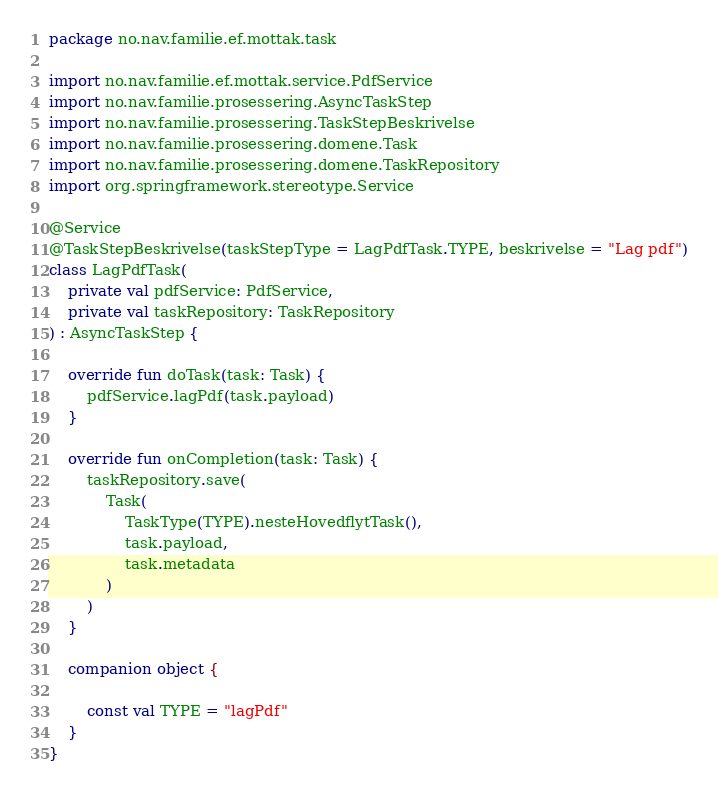<code> <loc_0><loc_0><loc_500><loc_500><_Kotlin_>package no.nav.familie.ef.mottak.task

import no.nav.familie.ef.mottak.service.PdfService
import no.nav.familie.prosessering.AsyncTaskStep
import no.nav.familie.prosessering.TaskStepBeskrivelse
import no.nav.familie.prosessering.domene.Task
import no.nav.familie.prosessering.domene.TaskRepository
import org.springframework.stereotype.Service

@Service
@TaskStepBeskrivelse(taskStepType = LagPdfTask.TYPE, beskrivelse = "Lag pdf")
class LagPdfTask(
    private val pdfService: PdfService,
    private val taskRepository: TaskRepository
) : AsyncTaskStep {

    override fun doTask(task: Task) {
        pdfService.lagPdf(task.payload)
    }

    override fun onCompletion(task: Task) {
        taskRepository.save(
            Task(
                TaskType(TYPE).nesteHovedflytTask(),
                task.payload,
                task.metadata
            )
        )
    }

    companion object {

        const val TYPE = "lagPdf"
    }
}
</code> 